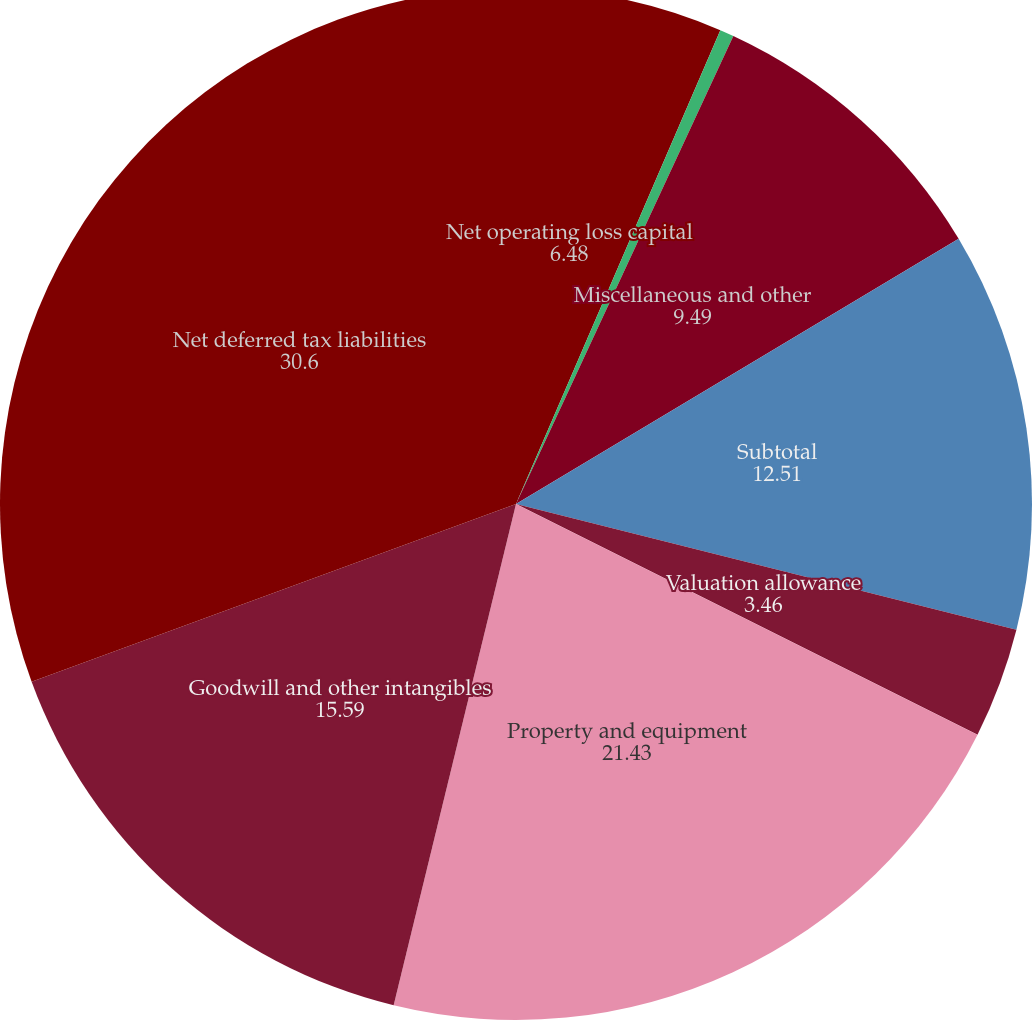Convert chart. <chart><loc_0><loc_0><loc_500><loc_500><pie_chart><fcel>Net operating loss capital<fcel>Landfill and environmental<fcel>Miscellaneous and other<fcel>Subtotal<fcel>Valuation allowance<fcel>Property and equipment<fcel>Goodwill and other intangibles<fcel>Net deferred tax liabilities<nl><fcel>6.48%<fcel>0.44%<fcel>9.49%<fcel>12.51%<fcel>3.46%<fcel>21.43%<fcel>15.59%<fcel>30.6%<nl></chart> 